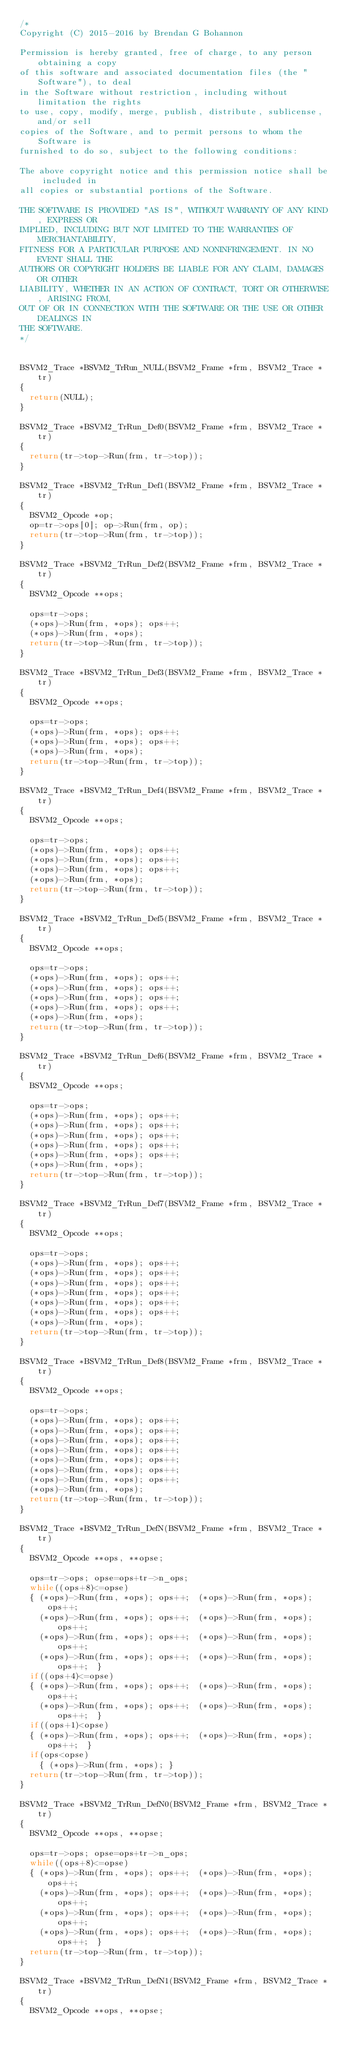<code> <loc_0><loc_0><loc_500><loc_500><_C_>/*
Copyright (C) 2015-2016 by Brendan G Bohannon

Permission is hereby granted, free of charge, to any person obtaining a copy
of this software and associated documentation files (the "Software"), to deal
in the Software without restriction, including without limitation the rights
to use, copy, modify, merge, publish, distribute, sublicense, and/or sell
copies of the Software, and to permit persons to whom the Software is
furnished to do so, subject to the following conditions:

The above copyright notice and this permission notice shall be included in
all copies or substantial portions of the Software.

THE SOFTWARE IS PROVIDED "AS IS", WITHOUT WARRANTY OF ANY KIND, EXPRESS OR
IMPLIED, INCLUDING BUT NOT LIMITED TO THE WARRANTIES OF MERCHANTABILITY,
FITNESS FOR A PARTICULAR PURPOSE AND NONINFRINGEMENT. IN NO EVENT SHALL THE
AUTHORS OR COPYRIGHT HOLDERS BE LIABLE FOR ANY CLAIM, DAMAGES OR OTHER
LIABILITY, WHETHER IN AN ACTION OF CONTRACT, TORT OR OTHERWISE, ARISING FROM,
OUT OF OR IN CONNECTION WITH THE SOFTWARE OR THE USE OR OTHER DEALINGS IN
THE SOFTWARE.
*/


BSVM2_Trace *BSVM2_TrRun_NULL(BSVM2_Frame *frm, BSVM2_Trace *tr)
{
	return(NULL);
}

BSVM2_Trace *BSVM2_TrRun_Def0(BSVM2_Frame *frm, BSVM2_Trace *tr)
{
	return(tr->top->Run(frm, tr->top));
}

BSVM2_Trace *BSVM2_TrRun_Def1(BSVM2_Frame *frm, BSVM2_Trace *tr)
{
	BSVM2_Opcode *op;
	op=tr->ops[0]; op->Run(frm, op);
	return(tr->top->Run(frm, tr->top));
}

BSVM2_Trace *BSVM2_TrRun_Def2(BSVM2_Frame *frm, BSVM2_Trace *tr)
{
	BSVM2_Opcode **ops;
	
	ops=tr->ops;
	(*ops)->Run(frm, *ops); ops++;
	(*ops)->Run(frm, *ops);
	return(tr->top->Run(frm, tr->top));
}

BSVM2_Trace *BSVM2_TrRun_Def3(BSVM2_Frame *frm, BSVM2_Trace *tr)
{
	BSVM2_Opcode **ops;
	
	ops=tr->ops;
	(*ops)->Run(frm, *ops); ops++;
	(*ops)->Run(frm, *ops); ops++;
	(*ops)->Run(frm, *ops);
	return(tr->top->Run(frm, tr->top));
}

BSVM2_Trace *BSVM2_TrRun_Def4(BSVM2_Frame *frm, BSVM2_Trace *tr)
{
	BSVM2_Opcode **ops;
	
	ops=tr->ops;
	(*ops)->Run(frm, *ops); ops++;
	(*ops)->Run(frm, *ops); ops++;
	(*ops)->Run(frm, *ops); ops++;
	(*ops)->Run(frm, *ops);
	return(tr->top->Run(frm, tr->top));
}

BSVM2_Trace *BSVM2_TrRun_Def5(BSVM2_Frame *frm, BSVM2_Trace *tr)
{
	BSVM2_Opcode **ops;
	
	ops=tr->ops;
	(*ops)->Run(frm, *ops); ops++;
	(*ops)->Run(frm, *ops); ops++;
	(*ops)->Run(frm, *ops); ops++;
	(*ops)->Run(frm, *ops); ops++;
	(*ops)->Run(frm, *ops);
	return(tr->top->Run(frm, tr->top));
}

BSVM2_Trace *BSVM2_TrRun_Def6(BSVM2_Frame *frm, BSVM2_Trace *tr)
{
	BSVM2_Opcode **ops;
	
	ops=tr->ops;
	(*ops)->Run(frm, *ops); ops++;
	(*ops)->Run(frm, *ops); ops++;
	(*ops)->Run(frm, *ops); ops++;
	(*ops)->Run(frm, *ops); ops++;
	(*ops)->Run(frm, *ops); ops++;
	(*ops)->Run(frm, *ops);
	return(tr->top->Run(frm, tr->top));
}

BSVM2_Trace *BSVM2_TrRun_Def7(BSVM2_Frame *frm, BSVM2_Trace *tr)
{
	BSVM2_Opcode **ops;
	
	ops=tr->ops;
	(*ops)->Run(frm, *ops); ops++;
	(*ops)->Run(frm, *ops); ops++;
	(*ops)->Run(frm, *ops); ops++;
	(*ops)->Run(frm, *ops); ops++;
	(*ops)->Run(frm, *ops); ops++;
	(*ops)->Run(frm, *ops); ops++;
	(*ops)->Run(frm, *ops);
	return(tr->top->Run(frm, tr->top));
}

BSVM2_Trace *BSVM2_TrRun_Def8(BSVM2_Frame *frm, BSVM2_Trace *tr)
{
	BSVM2_Opcode **ops;
	
	ops=tr->ops;
	(*ops)->Run(frm, *ops); ops++;
	(*ops)->Run(frm, *ops); ops++;
	(*ops)->Run(frm, *ops); ops++;
	(*ops)->Run(frm, *ops); ops++;
	(*ops)->Run(frm, *ops); ops++;
	(*ops)->Run(frm, *ops); ops++;
	(*ops)->Run(frm, *ops); ops++;
	(*ops)->Run(frm, *ops);
	return(tr->top->Run(frm, tr->top));
}

BSVM2_Trace *BSVM2_TrRun_DefN(BSVM2_Frame *frm, BSVM2_Trace *tr)
{
	BSVM2_Opcode **ops, **opse;
	
	ops=tr->ops; opse=ops+tr->n_ops;
	while((ops+8)<=opse)
	{	(*ops)->Run(frm, *ops); ops++;	(*ops)->Run(frm, *ops); ops++;
		(*ops)->Run(frm, *ops); ops++;	(*ops)->Run(frm, *ops); ops++;
		(*ops)->Run(frm, *ops); ops++;	(*ops)->Run(frm, *ops); ops++;
		(*ops)->Run(frm, *ops); ops++;	(*ops)->Run(frm, *ops); ops++;	}
	if((ops+4)<=opse)
	{	(*ops)->Run(frm, *ops); ops++;	(*ops)->Run(frm, *ops); ops++;
		(*ops)->Run(frm, *ops); ops++;	(*ops)->Run(frm, *ops); ops++;	}
	if((ops+1)<opse)
	{	(*ops)->Run(frm, *ops); ops++;	(*ops)->Run(frm, *ops); ops++;	}
	if(ops<opse)
		{ (*ops)->Run(frm, *ops); }
	return(tr->top->Run(frm, tr->top));
}

BSVM2_Trace *BSVM2_TrRun_DefN0(BSVM2_Frame *frm, BSVM2_Trace *tr)
{
	BSVM2_Opcode **ops, **opse;
	
	ops=tr->ops; opse=ops+tr->n_ops;
	while((ops+8)<=opse)
	{	(*ops)->Run(frm, *ops); ops++;	(*ops)->Run(frm, *ops); ops++;
		(*ops)->Run(frm, *ops); ops++;	(*ops)->Run(frm, *ops); ops++;
		(*ops)->Run(frm, *ops); ops++;	(*ops)->Run(frm, *ops); ops++;
		(*ops)->Run(frm, *ops); ops++;	(*ops)->Run(frm, *ops); ops++;	}
	return(tr->top->Run(frm, tr->top));
}

BSVM2_Trace *BSVM2_TrRun_DefN1(BSVM2_Frame *frm, BSVM2_Trace *tr)
{
	BSVM2_Opcode **ops, **opse;
	</code> 